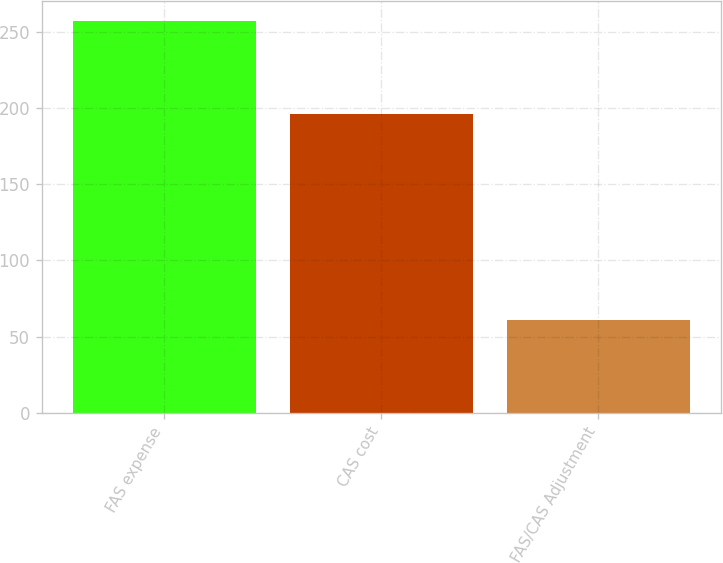Convert chart to OTSL. <chart><loc_0><loc_0><loc_500><loc_500><bar_chart><fcel>FAS expense<fcel>CAS cost<fcel>FAS/CAS Adjustment<nl><fcel>257<fcel>196<fcel>61<nl></chart> 